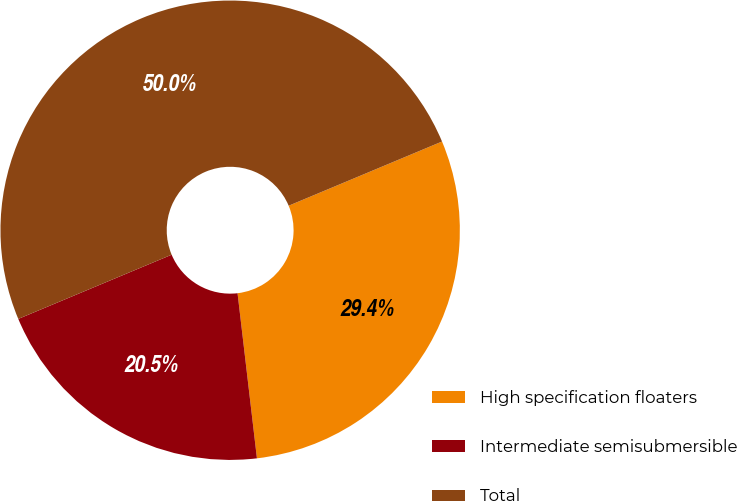Convert chart. <chart><loc_0><loc_0><loc_500><loc_500><pie_chart><fcel>High specification floaters<fcel>Intermediate semisubmersible<fcel>Total<nl><fcel>29.45%<fcel>20.55%<fcel>50.0%<nl></chart> 